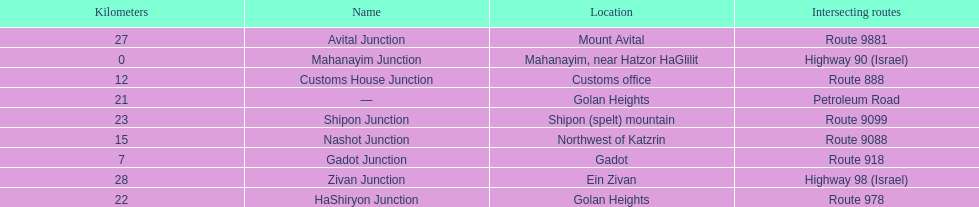Which junction on highway 91 is closer to ein zivan, gadot junction or shipon junction? Gadot Junction. 